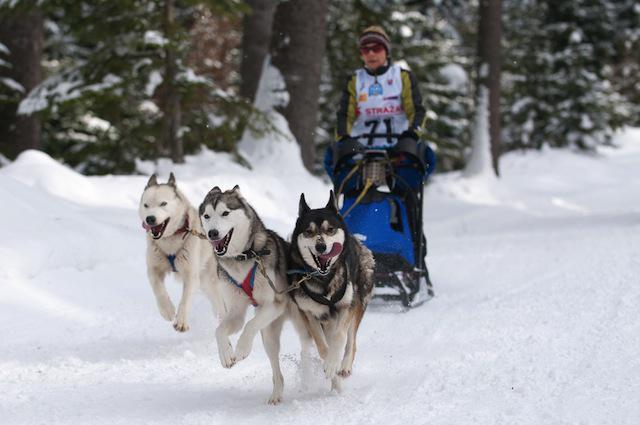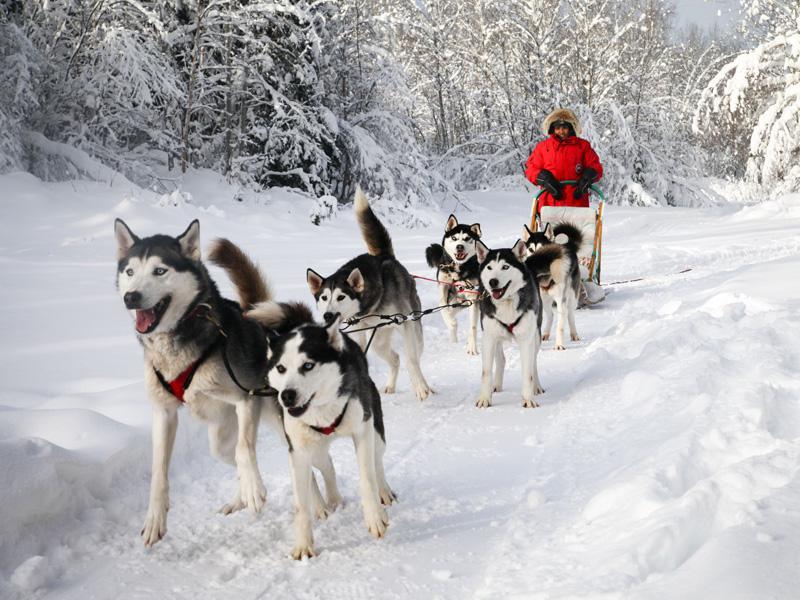The first image is the image on the left, the second image is the image on the right. Evaluate the accuracy of this statement regarding the images: "Only one person can be seen with each of two teams of dogs.". Is it true? Answer yes or no. Yes. The first image is the image on the left, the second image is the image on the right. Considering the images on both sides, is "One image features a sled driver wearing glasses and a white race vest." valid? Answer yes or no. Yes. 